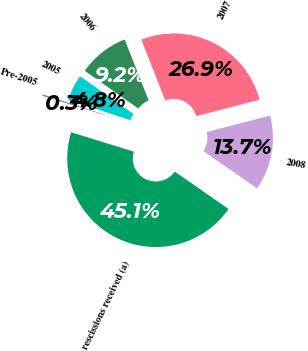Convert chart. <chart><loc_0><loc_0><loc_500><loc_500><pie_chart><fcel>Pre-2005<fcel>2005<fcel>2006<fcel>2007<fcel>2008<fcel>rescissions received (a)<nl><fcel>0.27%<fcel>4.75%<fcel>9.23%<fcel>26.93%<fcel>13.72%<fcel>45.1%<nl></chart> 